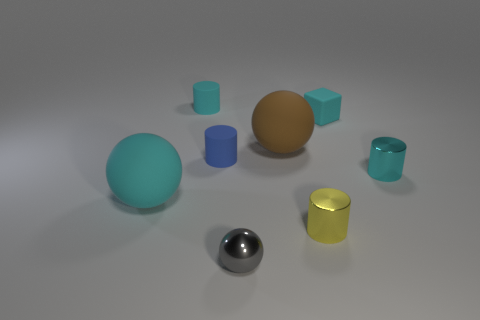How many cyan objects are both on the right side of the yellow metallic object and on the left side of the tiny cyan metal cylinder?
Your answer should be very brief. 1. Is there a object of the same color as the small matte cube?
Keep it short and to the point. Yes. What is the shape of the yellow metallic object that is the same size as the cyan metal thing?
Provide a succinct answer. Cylinder. Are there any large balls in front of the tiny cube?
Keep it short and to the point. Yes. Are the small cyan thing in front of the big brown ball and the small cyan cylinder that is to the left of the gray metal thing made of the same material?
Offer a terse response. No. How many cylinders have the same size as the cyan block?
Your answer should be compact. 4. There is a small rubber thing that is the same color as the rubber cube; what is its shape?
Provide a succinct answer. Cylinder. There is a big ball to the left of the large brown sphere; what material is it?
Your answer should be compact. Rubber. How many small cyan metallic objects are the same shape as the gray object?
Provide a short and direct response. 0. There is a small cyan thing that is made of the same material as the small yellow thing; what is its shape?
Offer a very short reply. Cylinder. 